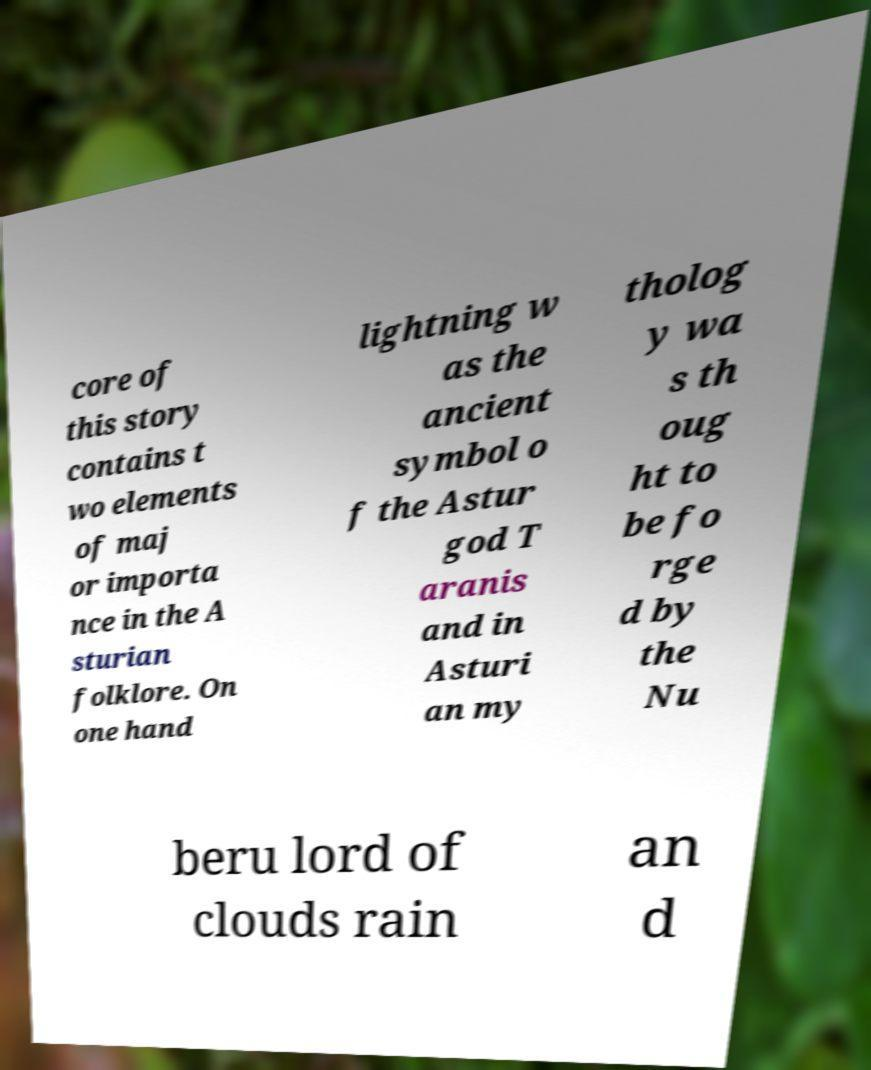What messages or text are displayed in this image? I need them in a readable, typed format. core of this story contains t wo elements of maj or importa nce in the A sturian folklore. On one hand lightning w as the ancient symbol o f the Astur god T aranis and in Asturi an my tholog y wa s th oug ht to be fo rge d by the Nu beru lord of clouds rain an d 